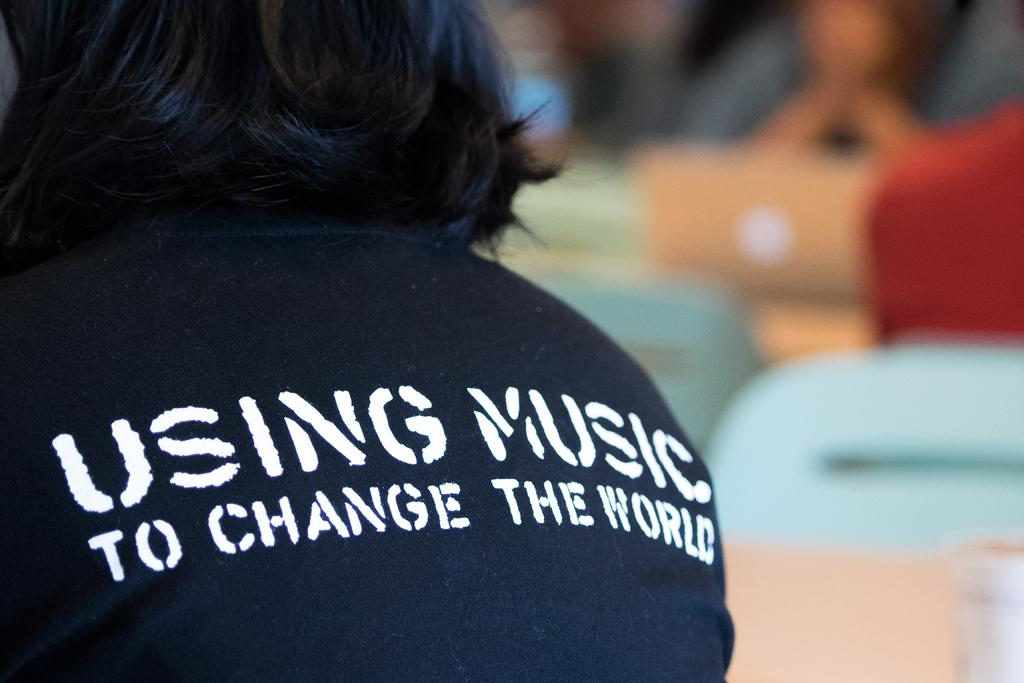What is the main subject of the image? There is a person in the image. Can you describe the background of the image? The background of the image is blurry. What can be seen on the person's t-shirt? There is text on the person's t-shirt. Where is the meeting taking place in the image? There is no meeting present in the image. What type of food can be seen in the lunchroom in the image? There is no lunchroom present in the image. 